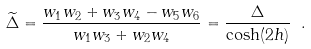<formula> <loc_0><loc_0><loc_500><loc_500>\widetilde { \Delta } = \frac { w _ { 1 } w _ { 2 } + w _ { 3 } w _ { 4 } - w _ { 5 } w _ { 6 } } { w _ { 1 } w _ { 3 } + w _ { 2 } w _ { 4 } } = \frac { \Delta } { \cosh ( 2 h ) } \ .</formula> 